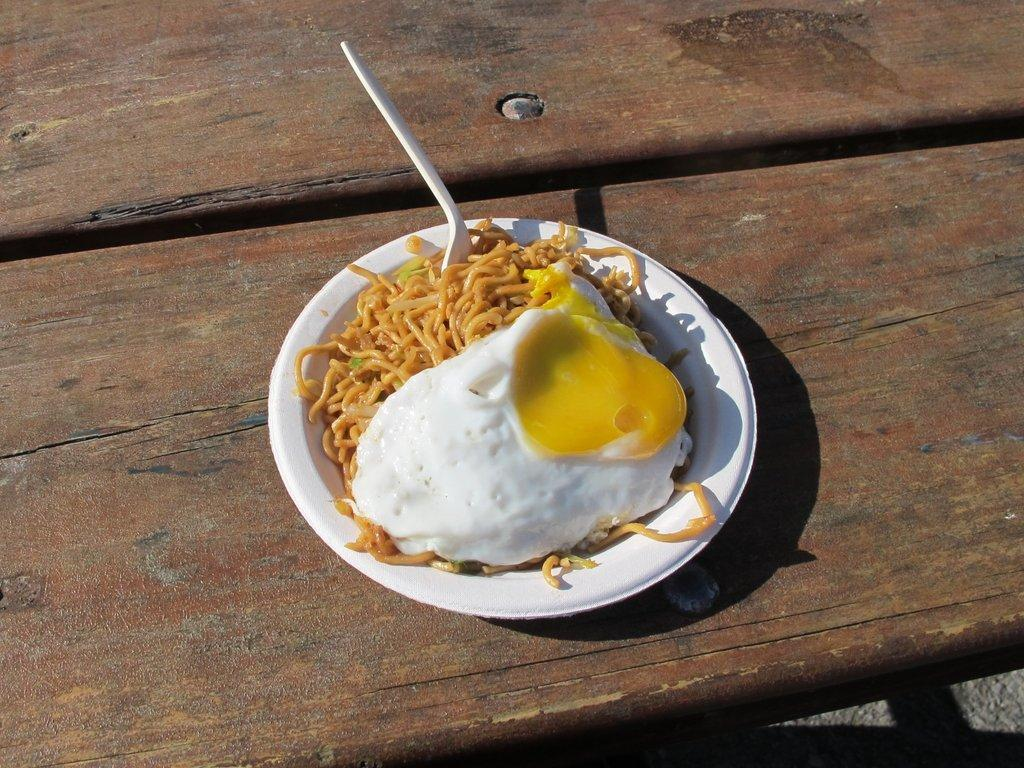What is on the plate that is visible in the image? The plate contains noodles and an egg omelette. What time of day is the image taken? The image is taken during the day. What type of wire can be seen connecting the quince to the jump in the image? There is no wire, quince, or jump present in the image. 